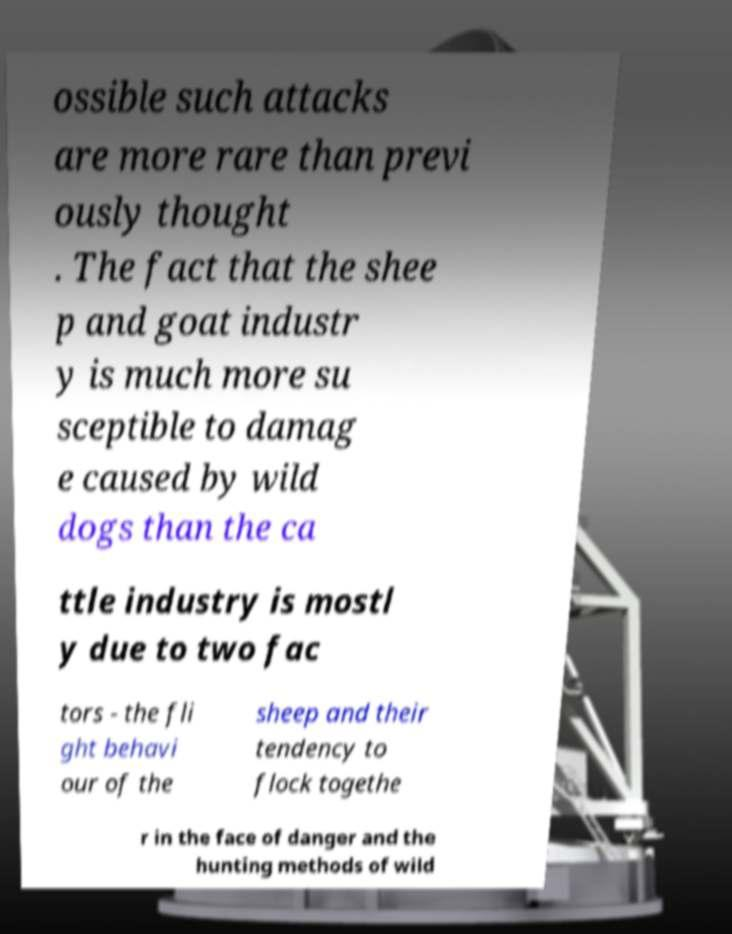Please identify and transcribe the text found in this image. ossible such attacks are more rare than previ ously thought . The fact that the shee p and goat industr y is much more su sceptible to damag e caused by wild dogs than the ca ttle industry is mostl y due to two fac tors - the fli ght behavi our of the sheep and their tendency to flock togethe r in the face of danger and the hunting methods of wild 